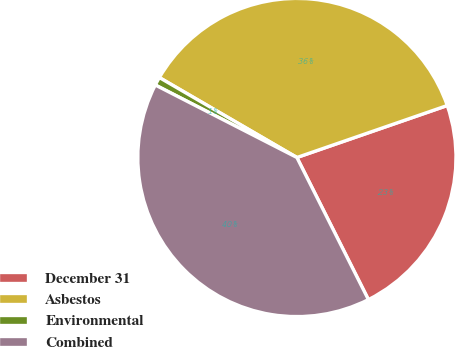Convert chart to OTSL. <chart><loc_0><loc_0><loc_500><loc_500><pie_chart><fcel>December 31<fcel>Asbestos<fcel>Environmental<fcel>Combined<nl><fcel>22.88%<fcel>36.32%<fcel>0.85%<fcel>39.95%<nl></chart> 